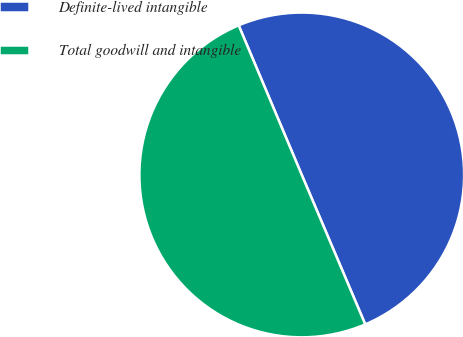Convert chart. <chart><loc_0><loc_0><loc_500><loc_500><pie_chart><fcel>Definite-lived intangible<fcel>Total goodwill and intangible<nl><fcel>49.96%<fcel>50.04%<nl></chart> 